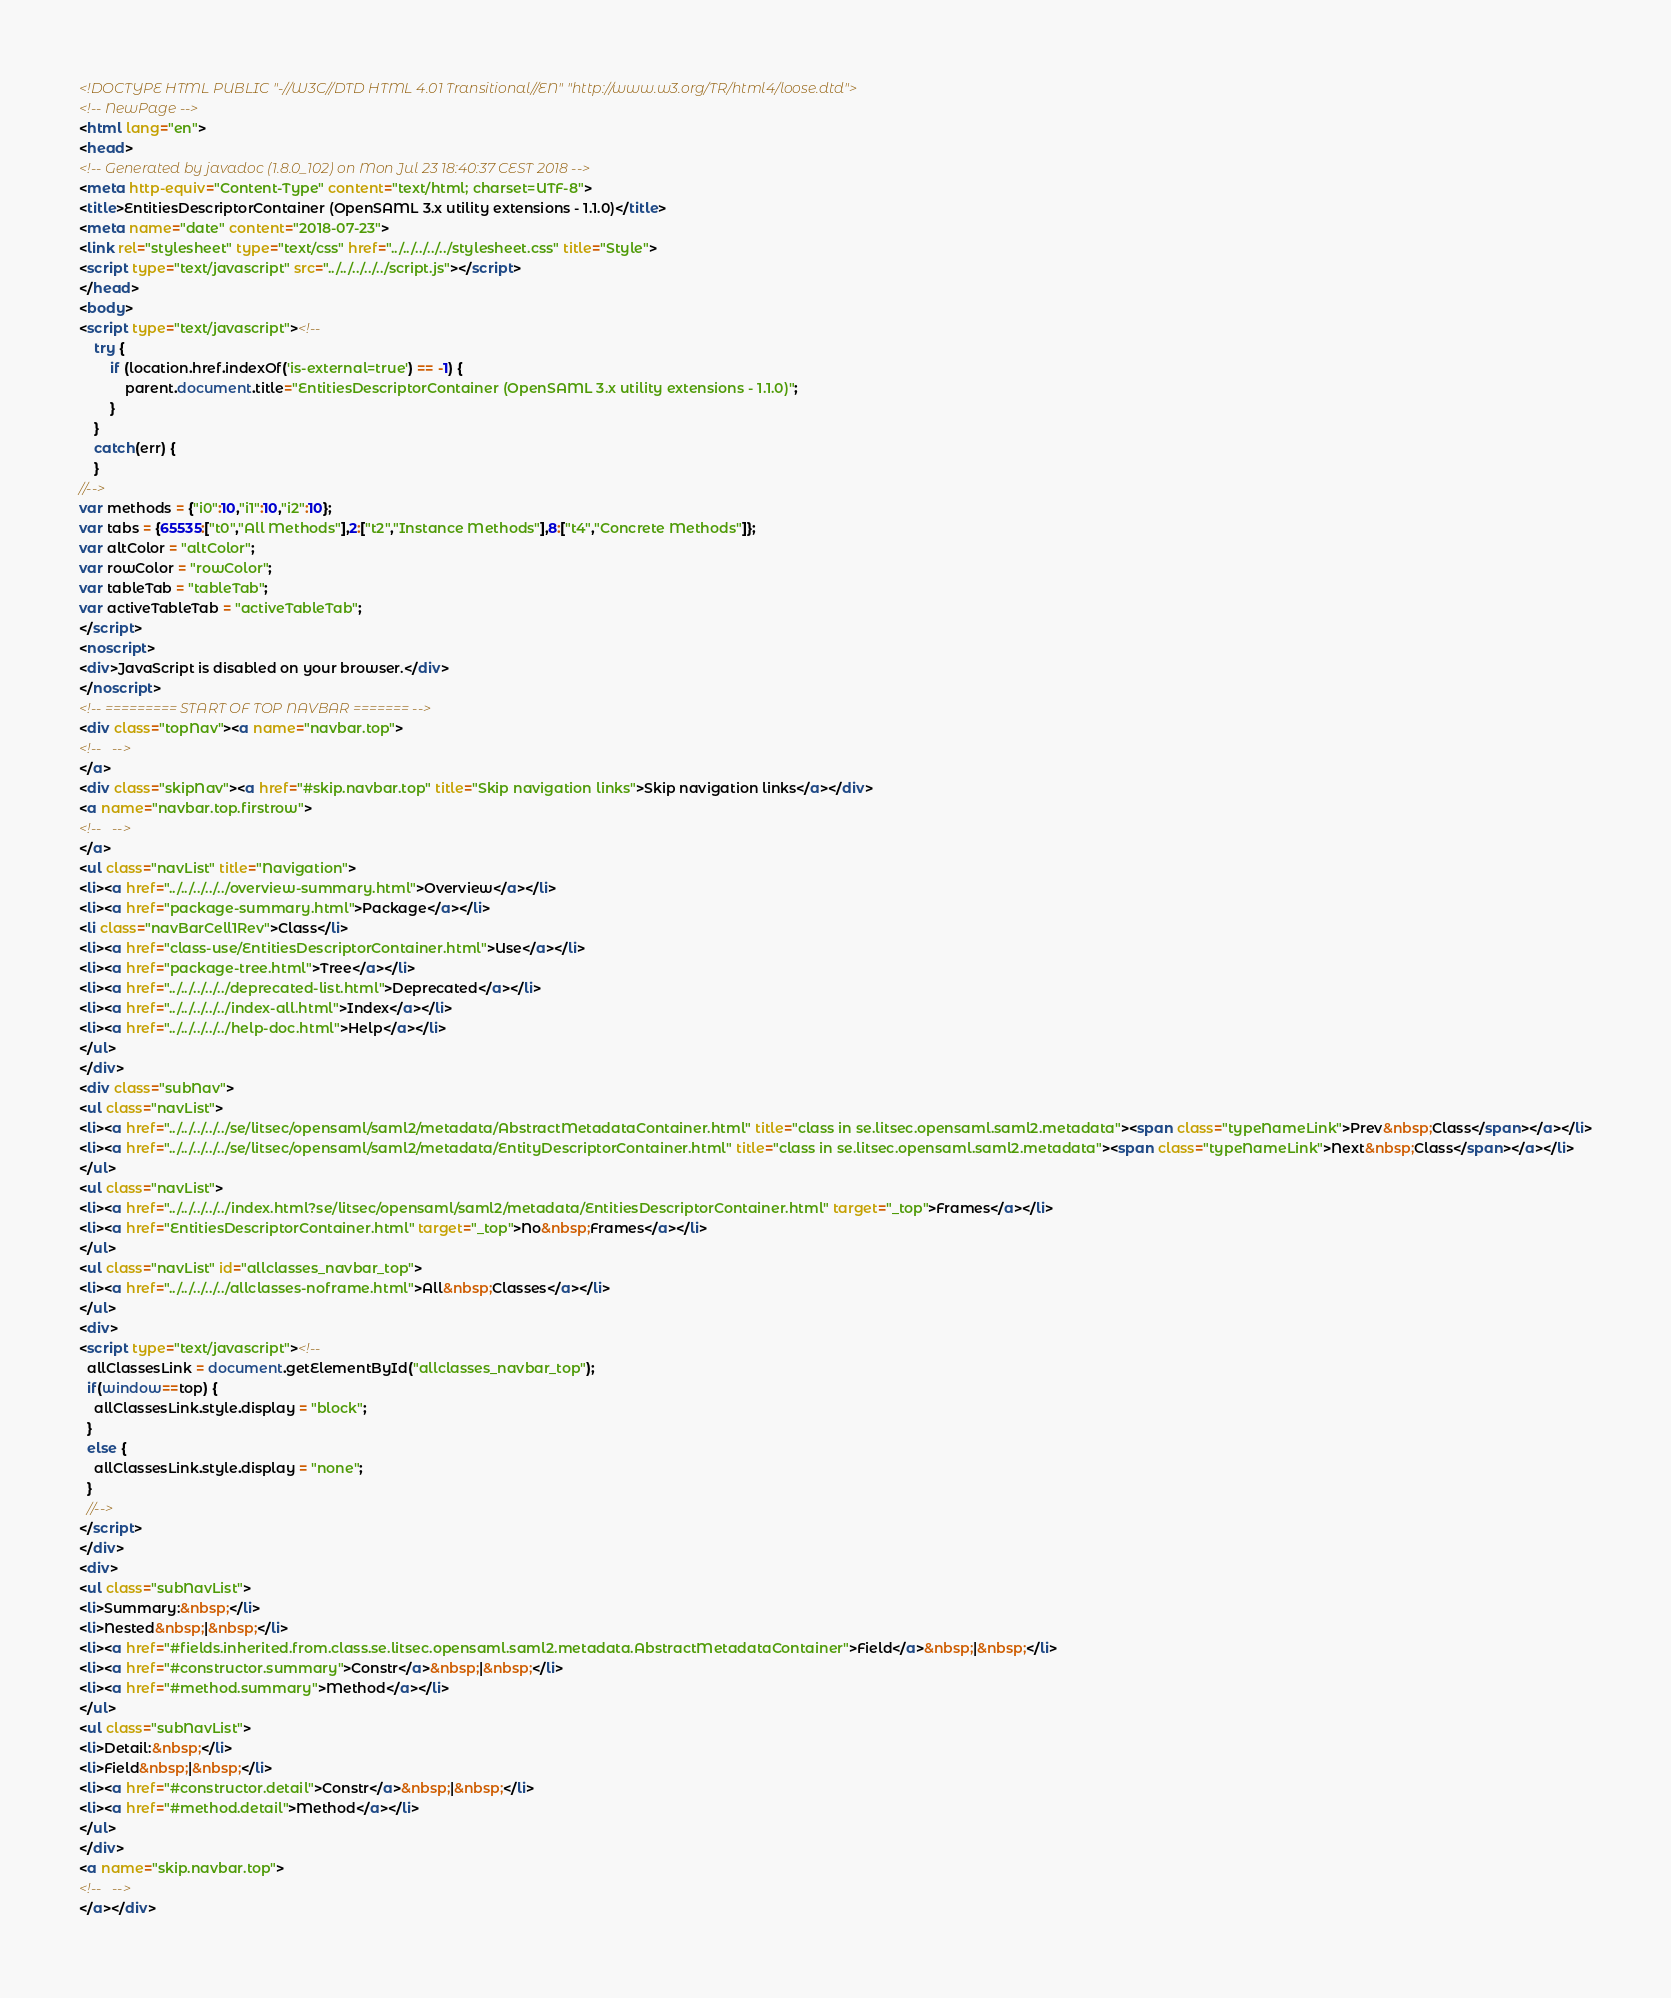<code> <loc_0><loc_0><loc_500><loc_500><_HTML_><!DOCTYPE HTML PUBLIC "-//W3C//DTD HTML 4.01 Transitional//EN" "http://www.w3.org/TR/html4/loose.dtd">
<!-- NewPage -->
<html lang="en">
<head>
<!-- Generated by javadoc (1.8.0_102) on Mon Jul 23 18:40:37 CEST 2018 -->
<meta http-equiv="Content-Type" content="text/html; charset=UTF-8">
<title>EntitiesDescriptorContainer (OpenSAML 3.x utility extensions - 1.1.0)</title>
<meta name="date" content="2018-07-23">
<link rel="stylesheet" type="text/css" href="../../../../../stylesheet.css" title="Style">
<script type="text/javascript" src="../../../../../script.js"></script>
</head>
<body>
<script type="text/javascript"><!--
    try {
        if (location.href.indexOf('is-external=true') == -1) {
            parent.document.title="EntitiesDescriptorContainer (OpenSAML 3.x utility extensions - 1.1.0)";
        }
    }
    catch(err) {
    }
//-->
var methods = {"i0":10,"i1":10,"i2":10};
var tabs = {65535:["t0","All Methods"],2:["t2","Instance Methods"],8:["t4","Concrete Methods"]};
var altColor = "altColor";
var rowColor = "rowColor";
var tableTab = "tableTab";
var activeTableTab = "activeTableTab";
</script>
<noscript>
<div>JavaScript is disabled on your browser.</div>
</noscript>
<!-- ========= START OF TOP NAVBAR ======= -->
<div class="topNav"><a name="navbar.top">
<!--   -->
</a>
<div class="skipNav"><a href="#skip.navbar.top" title="Skip navigation links">Skip navigation links</a></div>
<a name="navbar.top.firstrow">
<!--   -->
</a>
<ul class="navList" title="Navigation">
<li><a href="../../../../../overview-summary.html">Overview</a></li>
<li><a href="package-summary.html">Package</a></li>
<li class="navBarCell1Rev">Class</li>
<li><a href="class-use/EntitiesDescriptorContainer.html">Use</a></li>
<li><a href="package-tree.html">Tree</a></li>
<li><a href="../../../../../deprecated-list.html">Deprecated</a></li>
<li><a href="../../../../../index-all.html">Index</a></li>
<li><a href="../../../../../help-doc.html">Help</a></li>
</ul>
</div>
<div class="subNav">
<ul class="navList">
<li><a href="../../../../../se/litsec/opensaml/saml2/metadata/AbstractMetadataContainer.html" title="class in se.litsec.opensaml.saml2.metadata"><span class="typeNameLink">Prev&nbsp;Class</span></a></li>
<li><a href="../../../../../se/litsec/opensaml/saml2/metadata/EntityDescriptorContainer.html" title="class in se.litsec.opensaml.saml2.metadata"><span class="typeNameLink">Next&nbsp;Class</span></a></li>
</ul>
<ul class="navList">
<li><a href="../../../../../index.html?se/litsec/opensaml/saml2/metadata/EntitiesDescriptorContainer.html" target="_top">Frames</a></li>
<li><a href="EntitiesDescriptorContainer.html" target="_top">No&nbsp;Frames</a></li>
</ul>
<ul class="navList" id="allclasses_navbar_top">
<li><a href="../../../../../allclasses-noframe.html">All&nbsp;Classes</a></li>
</ul>
<div>
<script type="text/javascript"><!--
  allClassesLink = document.getElementById("allclasses_navbar_top");
  if(window==top) {
    allClassesLink.style.display = "block";
  }
  else {
    allClassesLink.style.display = "none";
  }
  //-->
</script>
</div>
<div>
<ul class="subNavList">
<li>Summary:&nbsp;</li>
<li>Nested&nbsp;|&nbsp;</li>
<li><a href="#fields.inherited.from.class.se.litsec.opensaml.saml2.metadata.AbstractMetadataContainer">Field</a>&nbsp;|&nbsp;</li>
<li><a href="#constructor.summary">Constr</a>&nbsp;|&nbsp;</li>
<li><a href="#method.summary">Method</a></li>
</ul>
<ul class="subNavList">
<li>Detail:&nbsp;</li>
<li>Field&nbsp;|&nbsp;</li>
<li><a href="#constructor.detail">Constr</a>&nbsp;|&nbsp;</li>
<li><a href="#method.detail">Method</a></li>
</ul>
</div>
<a name="skip.navbar.top">
<!--   -->
</a></div></code> 